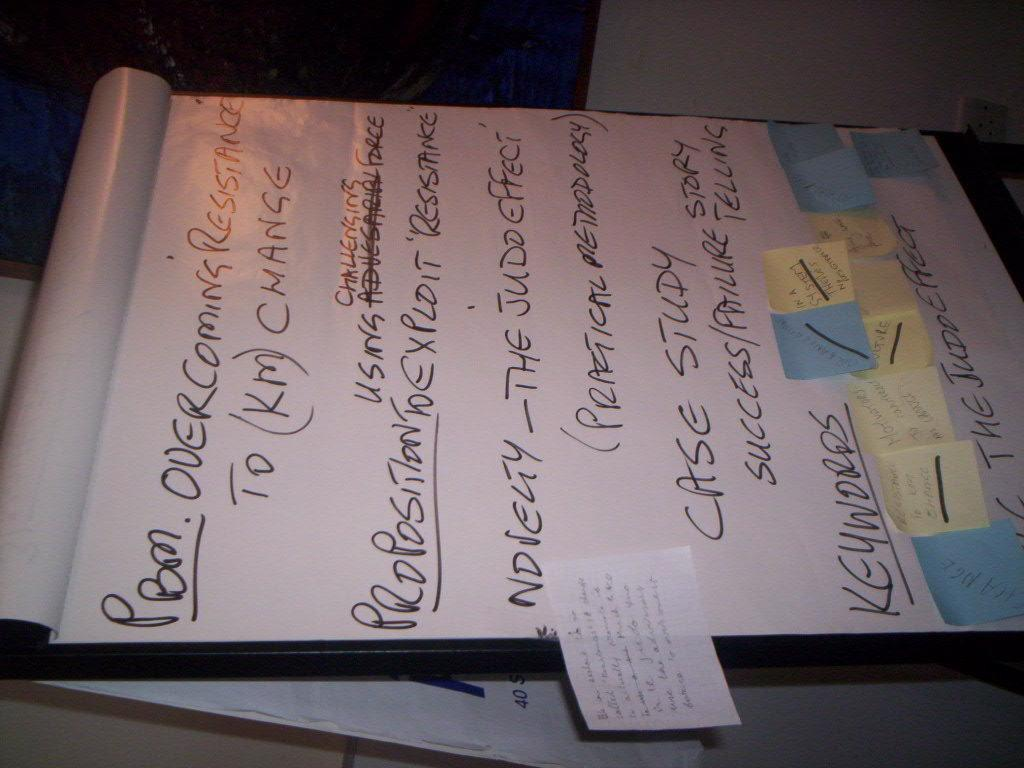Provide a one-sentence caption for the provided image. Some ideas about overcoming resistance are written on a large sheet. 